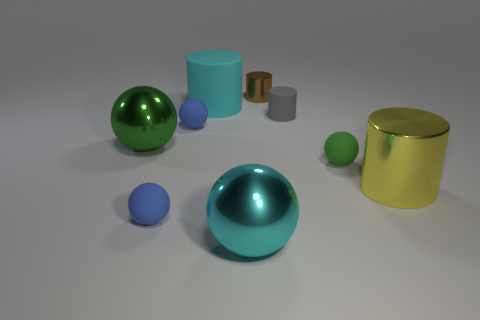Does the gray rubber cylinder have the same size as the metal sphere that is in front of the big yellow metal cylinder? No, the gray rubber cylinder does not have the same size as the metal sphere. The sphere is smaller in size compared to the cylinder. Observing their dimensions in relation to each other and their surroundings can help in making a more precise visual comparison. 